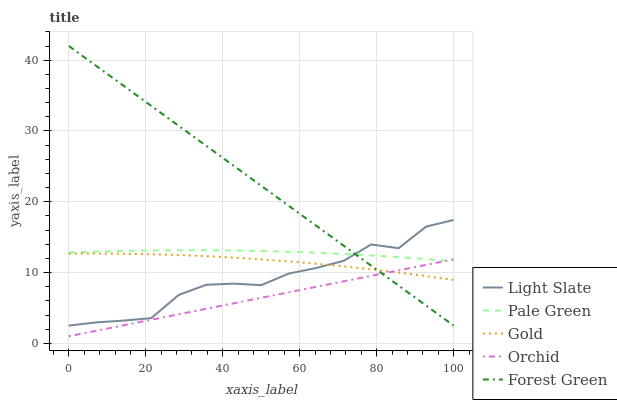Does Orchid have the minimum area under the curve?
Answer yes or no. Yes. Does Forest Green have the maximum area under the curve?
Answer yes or no. Yes. Does Pale Green have the minimum area under the curve?
Answer yes or no. No. Does Pale Green have the maximum area under the curve?
Answer yes or no. No. Is Orchid the smoothest?
Answer yes or no. Yes. Is Light Slate the roughest?
Answer yes or no. Yes. Is Forest Green the smoothest?
Answer yes or no. No. Is Forest Green the roughest?
Answer yes or no. No. Does Forest Green have the lowest value?
Answer yes or no. No. Does Forest Green have the highest value?
Answer yes or no. Yes. Does Pale Green have the highest value?
Answer yes or no. No. Is Orchid less than Light Slate?
Answer yes or no. Yes. Is Pale Green greater than Gold?
Answer yes or no. Yes. Does Forest Green intersect Light Slate?
Answer yes or no. Yes. Is Forest Green less than Light Slate?
Answer yes or no. No. Is Forest Green greater than Light Slate?
Answer yes or no. No. Does Orchid intersect Light Slate?
Answer yes or no. No. 